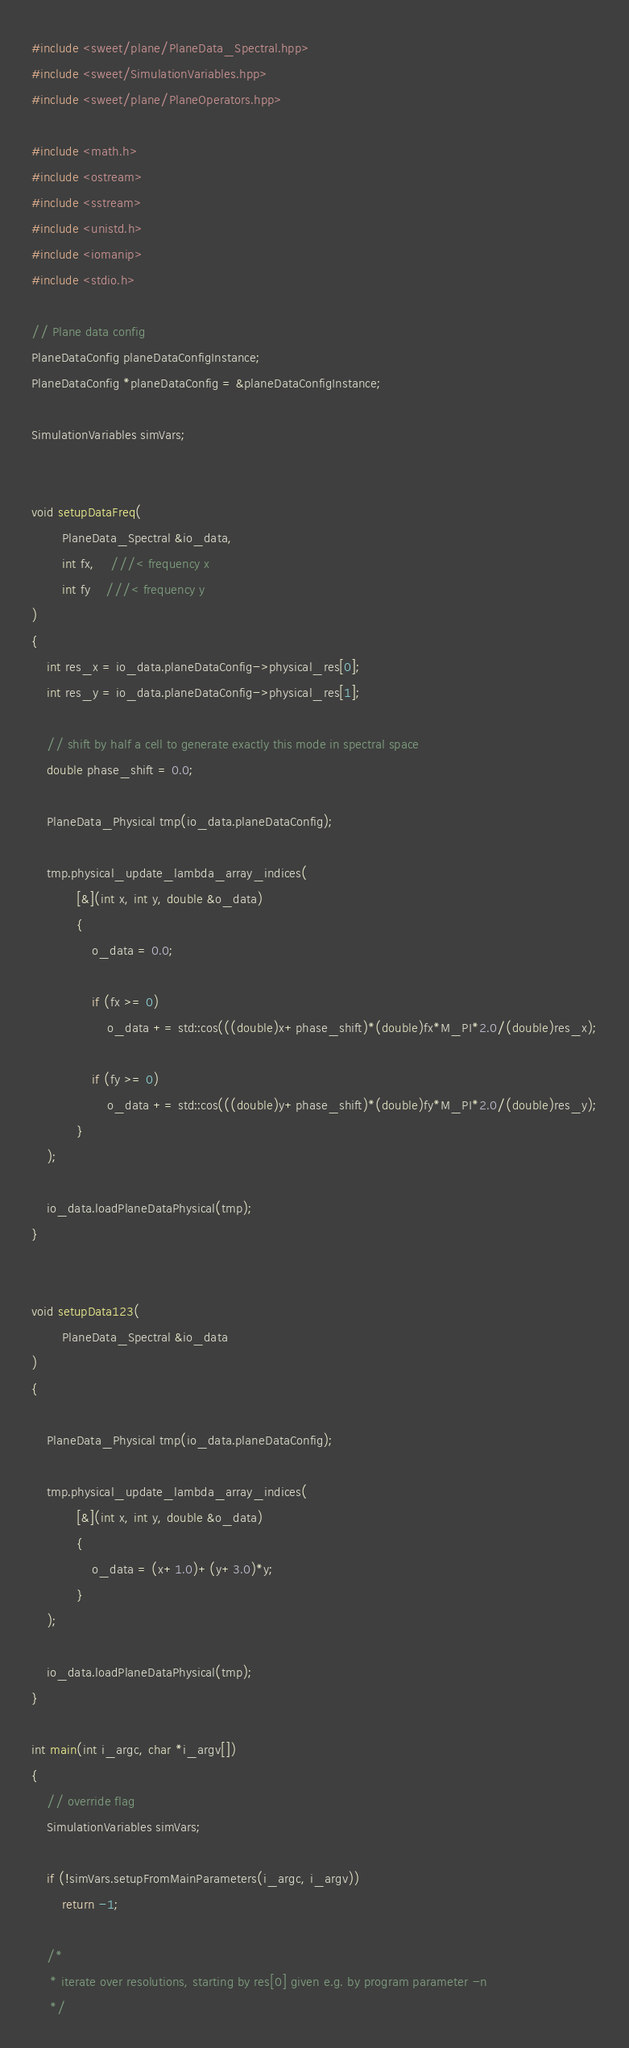<code> <loc_0><loc_0><loc_500><loc_500><_C++_>
#include <sweet/plane/PlaneData_Spectral.hpp>
#include <sweet/SimulationVariables.hpp>
#include <sweet/plane/PlaneOperators.hpp>

#include <math.h>
#include <ostream>
#include <sstream>
#include <unistd.h>
#include <iomanip>
#include <stdio.h>

// Plane data config
PlaneDataConfig planeDataConfigInstance;
PlaneDataConfig *planeDataConfig = &planeDataConfigInstance;

SimulationVariables simVars;


void setupDataFreq(
		PlaneData_Spectral &io_data,
		int fx,	///< frequency x
		int fy	///< frequency y
)
{
	int res_x = io_data.planeDataConfig->physical_res[0];
	int res_y = io_data.planeDataConfig->physical_res[1];

	// shift by half a cell to generate exactly this mode in spectral space
	double phase_shift = 0.0;

	PlaneData_Physical tmp(io_data.planeDataConfig);

	tmp.physical_update_lambda_array_indices(
			[&](int x, int y, double &o_data)
			{
				o_data = 0.0;

				if (fx >= 0)
					o_data += std::cos(((double)x+phase_shift)*(double)fx*M_PI*2.0/(double)res_x);

				if (fy >= 0)
					o_data += std::cos(((double)y+phase_shift)*(double)fy*M_PI*2.0/(double)res_y);
			}
	);

	io_data.loadPlaneDataPhysical(tmp);
}


void setupData123(
		PlaneData_Spectral &io_data
)
{

	PlaneData_Physical tmp(io_data.planeDataConfig);

	tmp.physical_update_lambda_array_indices(
			[&](int x, int y, double &o_data)
			{
				o_data = (x+1.0)+(y+3.0)*y;
			}
	);

	io_data.loadPlaneDataPhysical(tmp);
}

int main(int i_argc, char *i_argv[])
{
	// override flag
	SimulationVariables simVars;

	if (!simVars.setupFromMainParameters(i_argc, i_argv))
		return -1;

	/*
	 * iterate over resolutions, starting by res[0] given e.g. by program parameter -n
	 */
</code> 